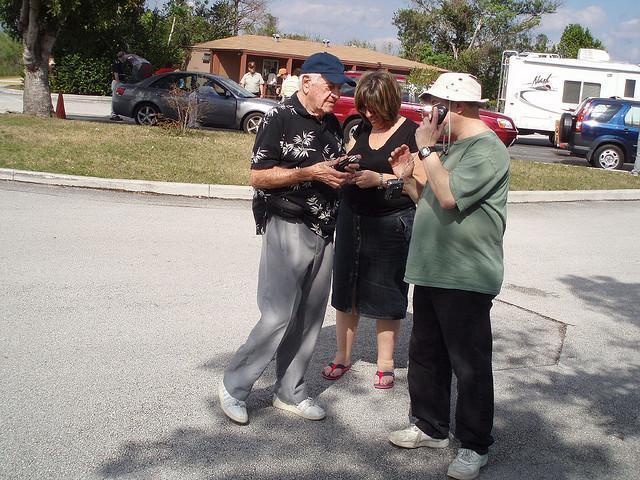How many people wear sneakers?
Give a very brief answer. 2. How many cars are there?
Give a very brief answer. 3. How many people can be seen?
Give a very brief answer. 3. How many different vases are there?
Give a very brief answer. 0. 